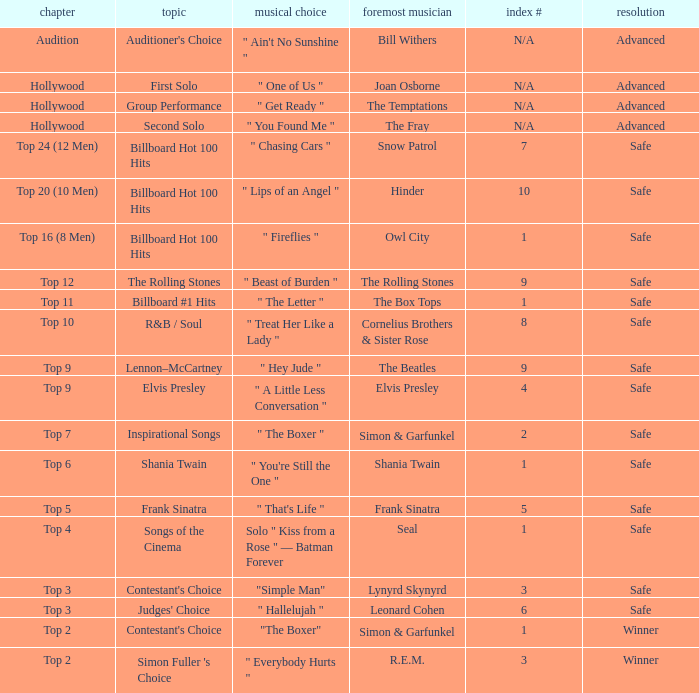The original artist Joan Osborne has what result? Advanced. 